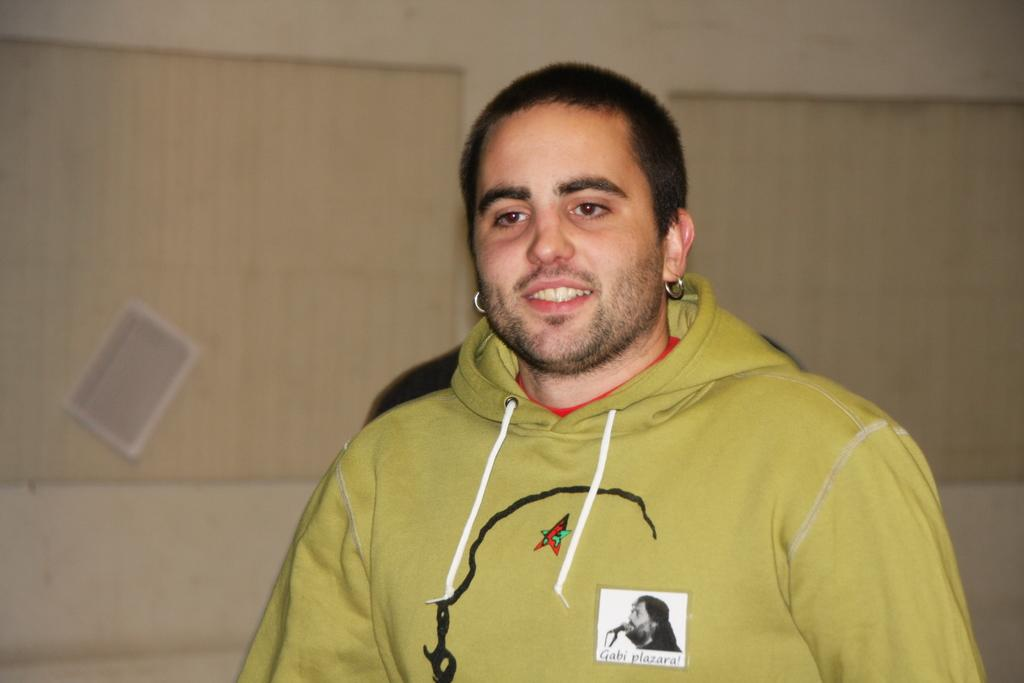Who is present in the image? There is a man in the image. What is the man's facial expression? The man is smiling. What can be seen in the background of the image? There is a wall in the background of the image. What type of animal is wearing a skirt in the image? There is no animal wearing a skirt in the image; it only features a man smiling in front of a wall. 